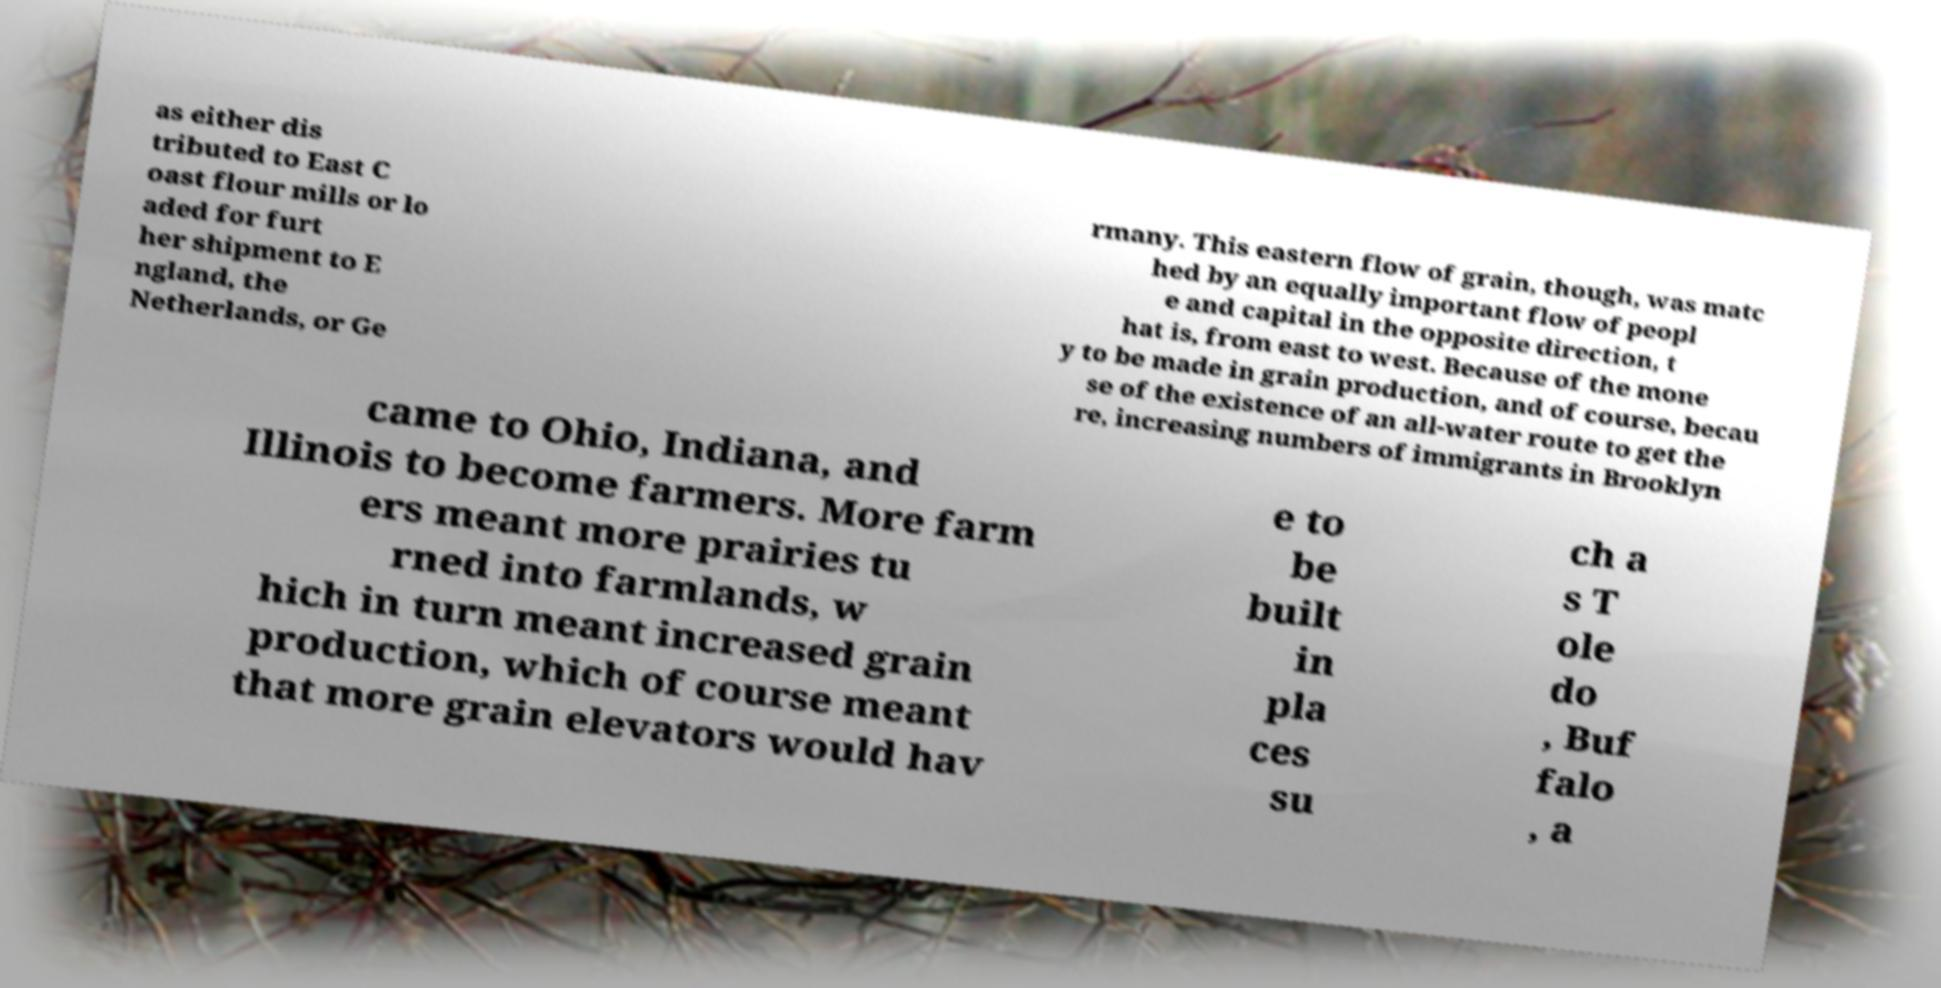Can you accurately transcribe the text from the provided image for me? as either dis tributed to East C oast flour mills or lo aded for furt her shipment to E ngland, the Netherlands, or Ge rmany. This eastern flow of grain, though, was matc hed by an equally important flow of peopl e and capital in the opposite direction, t hat is, from east to west. Because of the mone y to be made in grain production, and of course, becau se of the existence of an all-water route to get the re, increasing numbers of immigrants in Brooklyn came to Ohio, Indiana, and Illinois to become farmers. More farm ers meant more prairies tu rned into farmlands, w hich in turn meant increased grain production, which of course meant that more grain elevators would hav e to be built in pla ces su ch a s T ole do , Buf falo , a 